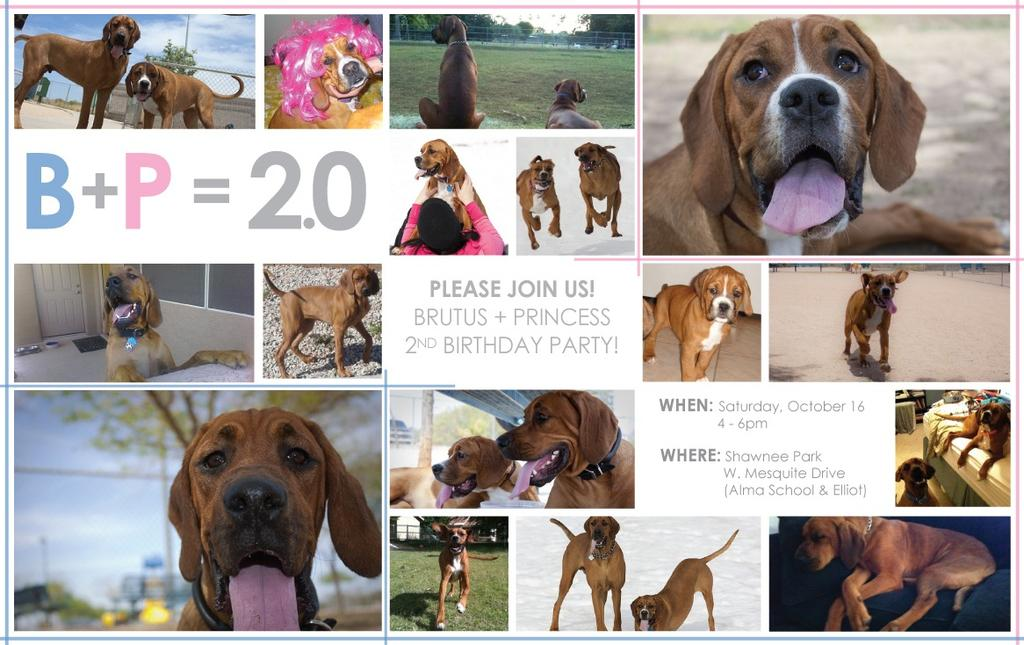What type of visual is the image in question? The image is a poster. What is the main subject of the poster? There are multiple images of dogs on the poster. Is there any text on the poster? Yes, there is text in the middle of the poster. How are the dog images arranged on the poster? The dog images are arranged in a collage around the text. Can you see any dust on the dogs in the image? There is no dust visible on the dogs in the image, as it is a poster with images of dogs and not a photograph of real dogs. Is there a zoo mentioned in the text on the poster? The provided facts do not mention any text related to a zoo, so it cannot be determined if a zoo is mentioned in the text. 